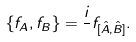<formula> <loc_0><loc_0><loc_500><loc_500>\{ f _ { A } , f _ { B } \} = \frac { i } { } f _ { [ \hat { A } , \hat { B } ] } .</formula> 